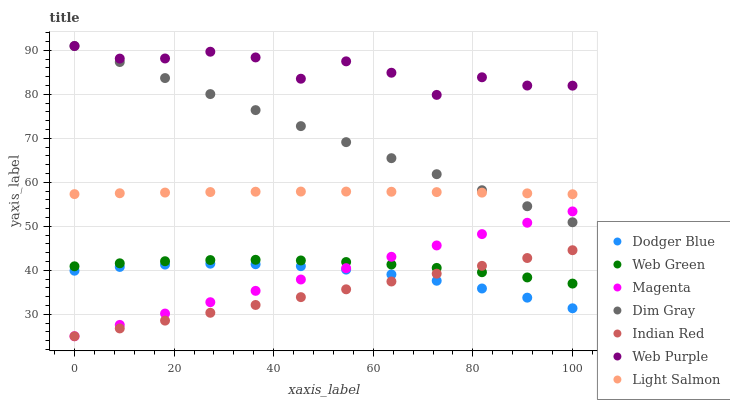Does Indian Red have the minimum area under the curve?
Answer yes or no. Yes. Does Web Purple have the maximum area under the curve?
Answer yes or no. Yes. Does Dim Gray have the minimum area under the curve?
Answer yes or no. No. Does Dim Gray have the maximum area under the curve?
Answer yes or no. No. Is Indian Red the smoothest?
Answer yes or no. Yes. Is Web Purple the roughest?
Answer yes or no. Yes. Is Dim Gray the smoothest?
Answer yes or no. No. Is Dim Gray the roughest?
Answer yes or no. No. Does Indian Red have the lowest value?
Answer yes or no. Yes. Does Dim Gray have the lowest value?
Answer yes or no. No. Does Web Purple have the highest value?
Answer yes or no. Yes. Does Web Green have the highest value?
Answer yes or no. No. Is Web Green less than Dim Gray?
Answer yes or no. Yes. Is Light Salmon greater than Magenta?
Answer yes or no. Yes. Does Dodger Blue intersect Magenta?
Answer yes or no. Yes. Is Dodger Blue less than Magenta?
Answer yes or no. No. Is Dodger Blue greater than Magenta?
Answer yes or no. No. Does Web Green intersect Dim Gray?
Answer yes or no. No. 